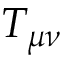Convert formula to latex. <formula><loc_0><loc_0><loc_500><loc_500>T _ { \mu \nu }</formula> 